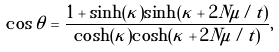<formula> <loc_0><loc_0><loc_500><loc_500>\cos \theta = \frac { 1 + \sinh ( \kappa ) \sinh ( \kappa + 2 N \mu / t ) } { \cosh ( \kappa ) \cosh ( \kappa + 2 N \mu / t ) } ,</formula> 